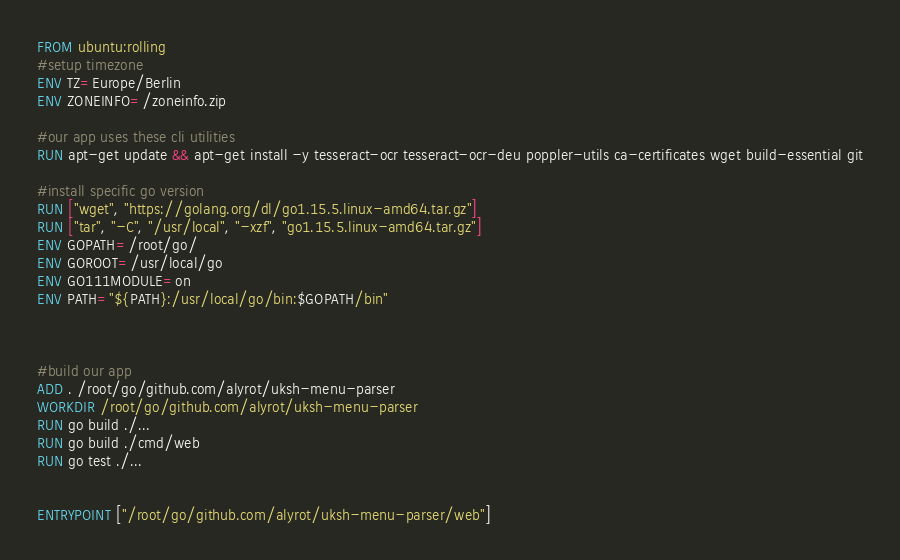<code> <loc_0><loc_0><loc_500><loc_500><_Dockerfile_>FROM ubuntu:rolling
#setup timezone
ENV TZ=Europe/Berlin
ENV ZONEINFO=/zoneinfo.zip

#our app uses these cli utilities
RUN apt-get update && apt-get install -y tesseract-ocr tesseract-ocr-deu poppler-utils ca-certificates wget build-essential git

#install specific go version
RUN ["wget", "https://golang.org/dl/go1.15.5.linux-amd64.tar.gz"]
RUN ["tar", "-C", "/usr/local", "-xzf", "go1.15.5.linux-amd64.tar.gz"]
ENV GOPATH=/root/go/
ENV GOROOT=/usr/local/go
ENV GO111MODULE=on
ENV PATH="${PATH}:/usr/local/go/bin:$GOPATH/bin"



#build our app
ADD . /root/go/github.com/alyrot/uksh-menu-parser
WORKDIR /root/go/github.com/alyrot/uksh-menu-parser
RUN go build ./...
RUN go build ./cmd/web
RUN go test ./...


ENTRYPOINT ["/root/go/github.com/alyrot/uksh-menu-parser/web"]

</code> 